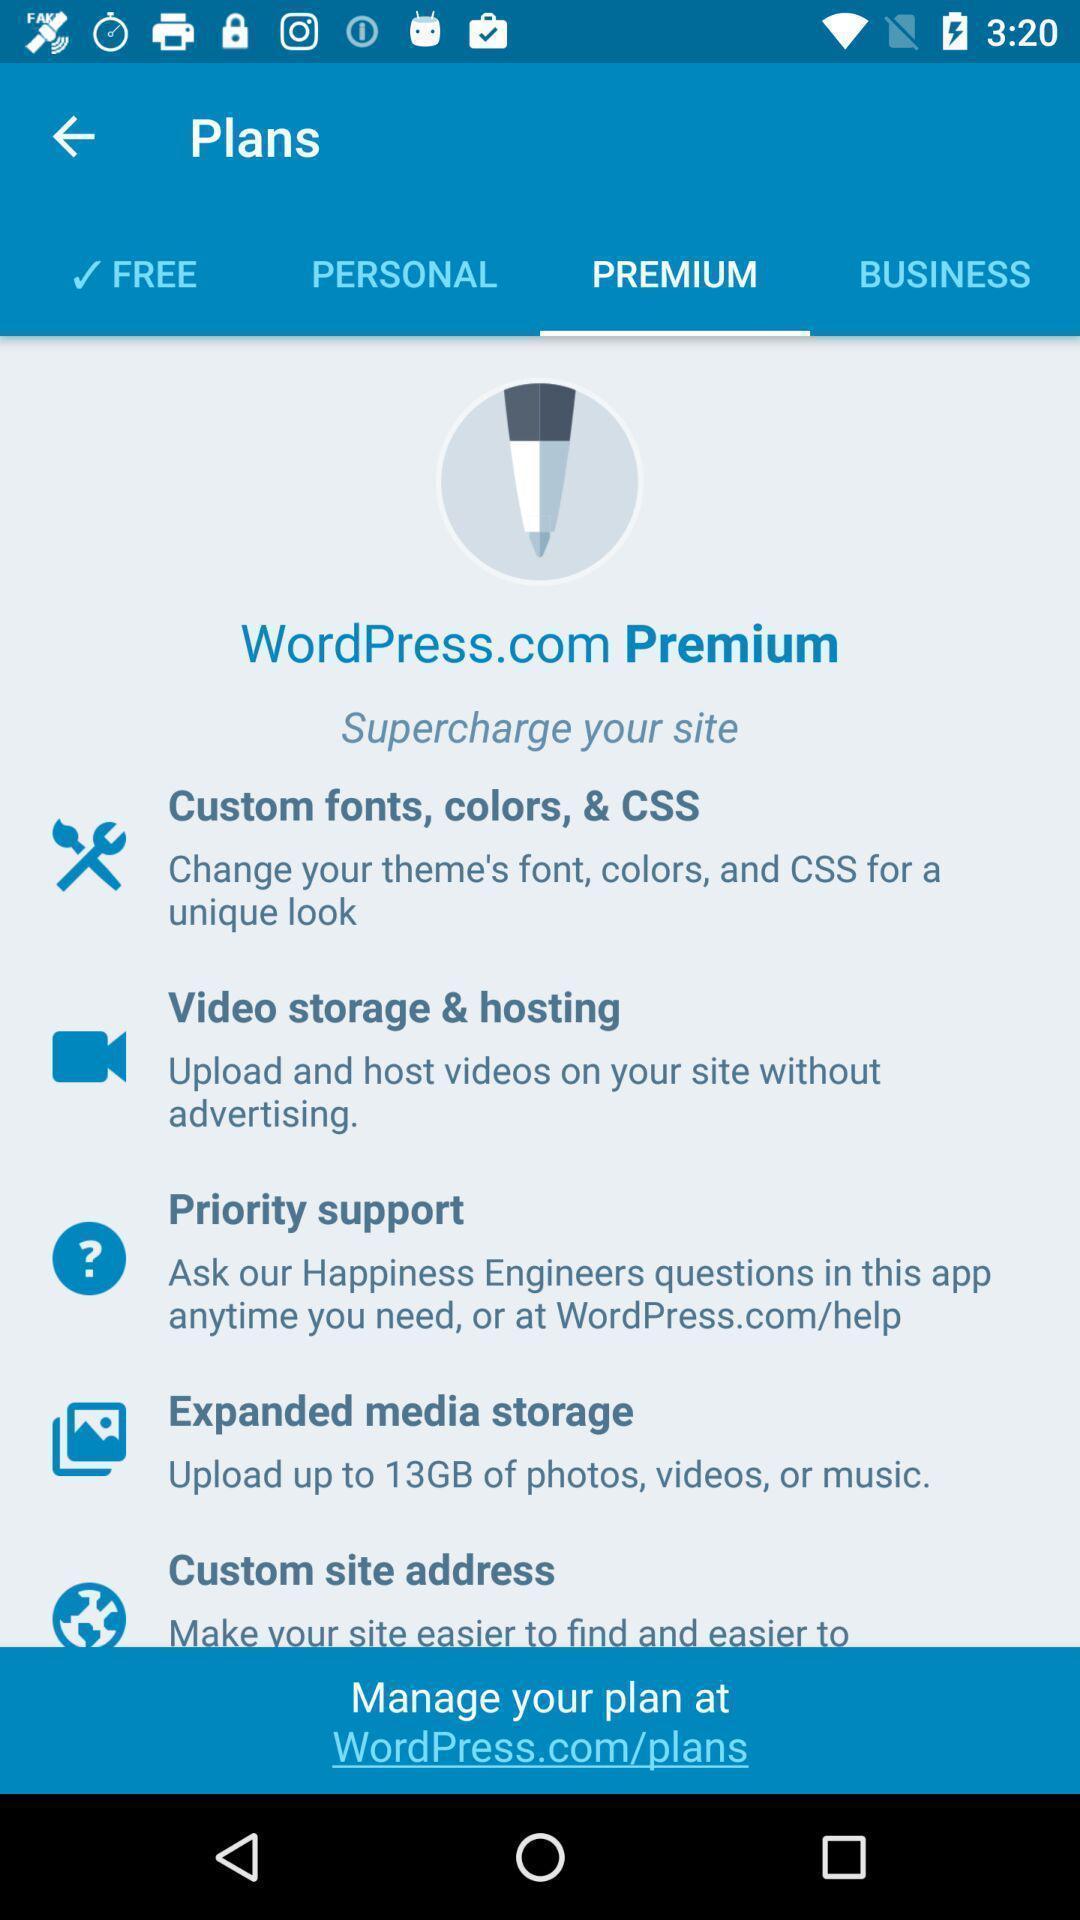Describe the visual elements of this screenshot. Page showing various plans for the user to choose. 